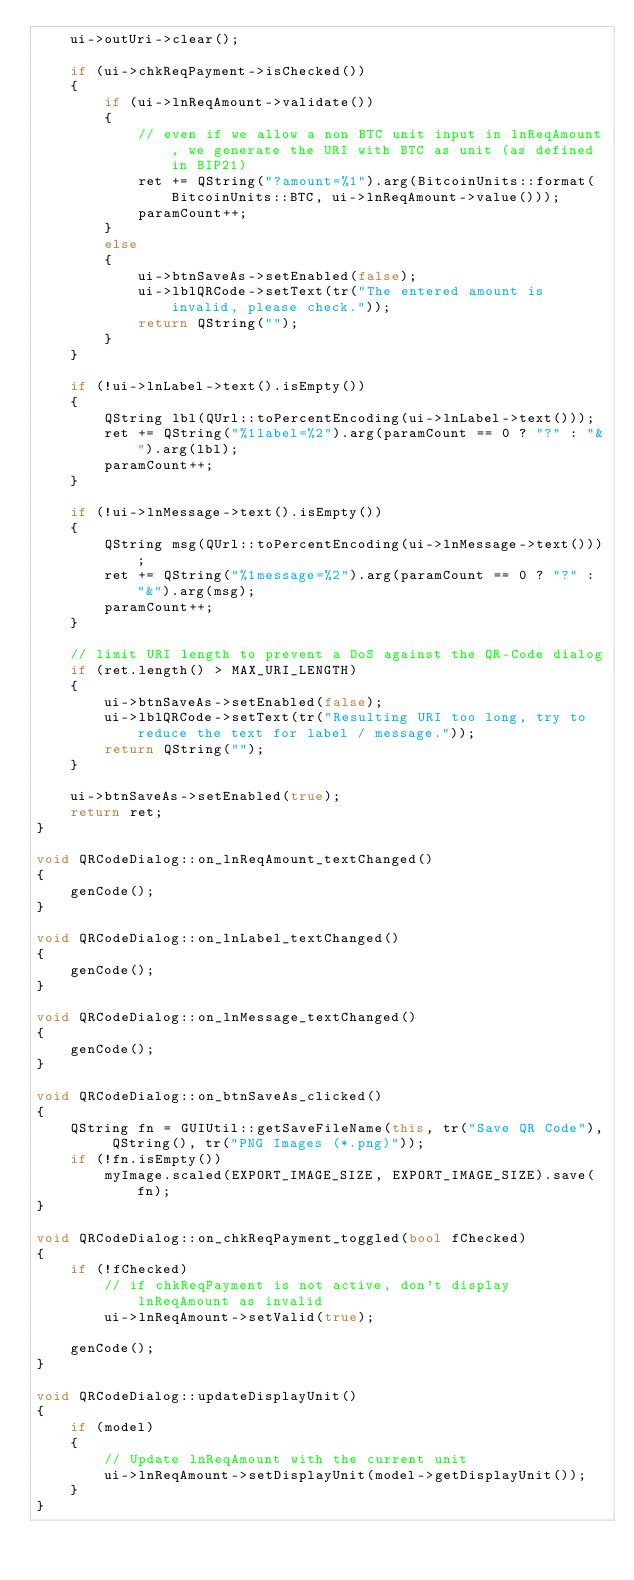<code> <loc_0><loc_0><loc_500><loc_500><_C++_>    ui->outUri->clear();

    if (ui->chkReqPayment->isChecked())
    {
        if (ui->lnReqAmount->validate())
        {
            // even if we allow a non BTC unit input in lnReqAmount, we generate the URI with BTC as unit (as defined in BIP21)
            ret += QString("?amount=%1").arg(BitcoinUnits::format(BitcoinUnits::BTC, ui->lnReqAmount->value()));
            paramCount++;
        }
        else
        {
            ui->btnSaveAs->setEnabled(false);
            ui->lblQRCode->setText(tr("The entered amount is invalid, please check."));
            return QString("");
        }
    }

    if (!ui->lnLabel->text().isEmpty())
    {
        QString lbl(QUrl::toPercentEncoding(ui->lnLabel->text()));
        ret += QString("%1label=%2").arg(paramCount == 0 ? "?" : "&").arg(lbl);
        paramCount++;
    }

    if (!ui->lnMessage->text().isEmpty())
    {
        QString msg(QUrl::toPercentEncoding(ui->lnMessage->text()));
        ret += QString("%1message=%2").arg(paramCount == 0 ? "?" : "&").arg(msg);
        paramCount++;
    }

    // limit URI length to prevent a DoS against the QR-Code dialog
    if (ret.length() > MAX_URI_LENGTH)
    {
        ui->btnSaveAs->setEnabled(false);
        ui->lblQRCode->setText(tr("Resulting URI too long, try to reduce the text for label / message."));
        return QString("");
    }

    ui->btnSaveAs->setEnabled(true);
    return ret;
}

void QRCodeDialog::on_lnReqAmount_textChanged()
{
    genCode();
}

void QRCodeDialog::on_lnLabel_textChanged()
{
    genCode();
}

void QRCodeDialog::on_lnMessage_textChanged()
{
    genCode();
}

void QRCodeDialog::on_btnSaveAs_clicked()
{
    QString fn = GUIUtil::getSaveFileName(this, tr("Save QR Code"), QString(), tr("PNG Images (*.png)"));
    if (!fn.isEmpty())
        myImage.scaled(EXPORT_IMAGE_SIZE, EXPORT_IMAGE_SIZE).save(fn);
}

void QRCodeDialog::on_chkReqPayment_toggled(bool fChecked)
{
    if (!fChecked)
        // if chkReqPayment is not active, don't display lnReqAmount as invalid
        ui->lnReqAmount->setValid(true);

    genCode();
}

void QRCodeDialog::updateDisplayUnit()
{
    if (model)
    {
        // Update lnReqAmount with the current unit
        ui->lnReqAmount->setDisplayUnit(model->getDisplayUnit());
    }
}
</code> 